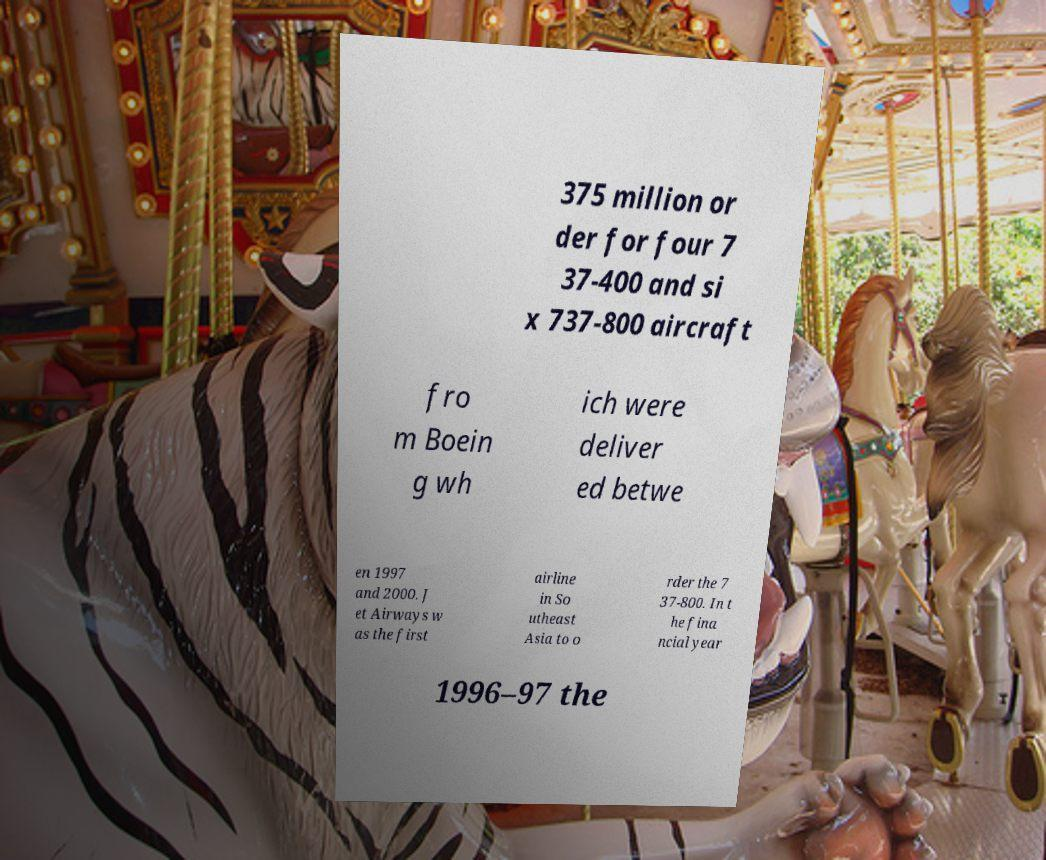Please read and relay the text visible in this image. What does it say? 375 million or der for four 7 37-400 and si x 737-800 aircraft fro m Boein g wh ich were deliver ed betwe en 1997 and 2000. J et Airways w as the first airline in So utheast Asia to o rder the 7 37-800. In t he fina ncial year 1996–97 the 